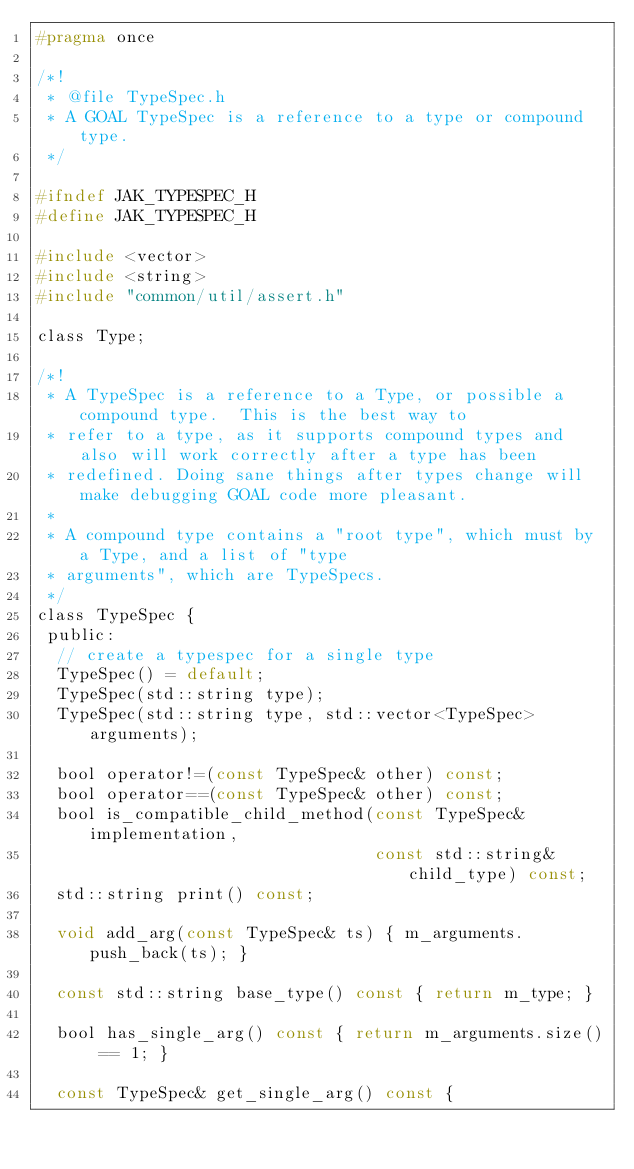Convert code to text. <code><loc_0><loc_0><loc_500><loc_500><_C_>#pragma once

/*!
 * @file TypeSpec.h
 * A GOAL TypeSpec is a reference to a type or compound type.
 */

#ifndef JAK_TYPESPEC_H
#define JAK_TYPESPEC_H

#include <vector>
#include <string>
#include "common/util/assert.h"

class Type;

/*!
 * A TypeSpec is a reference to a Type, or possible a compound type.  This is the best way to
 * refer to a type, as it supports compound types and also will work correctly after a type has been
 * redefined. Doing sane things after types change will make debugging GOAL code more pleasant.
 *
 * A compound type contains a "root type", which must by a Type, and a list of "type
 * arguments", which are TypeSpecs.
 */
class TypeSpec {
 public:
  // create a typespec for a single type
  TypeSpec() = default;
  TypeSpec(std::string type);
  TypeSpec(std::string type, std::vector<TypeSpec> arguments);

  bool operator!=(const TypeSpec& other) const;
  bool operator==(const TypeSpec& other) const;
  bool is_compatible_child_method(const TypeSpec& implementation,
                                  const std::string& child_type) const;
  std::string print() const;

  void add_arg(const TypeSpec& ts) { m_arguments.push_back(ts); }

  const std::string base_type() const { return m_type; }

  bool has_single_arg() const { return m_arguments.size() == 1; }

  const TypeSpec& get_single_arg() const {</code> 